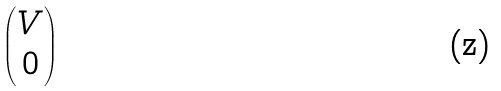Convert formula to latex. <formula><loc_0><loc_0><loc_500><loc_500>\begin{pmatrix} V \\ 0 \end{pmatrix}</formula> 